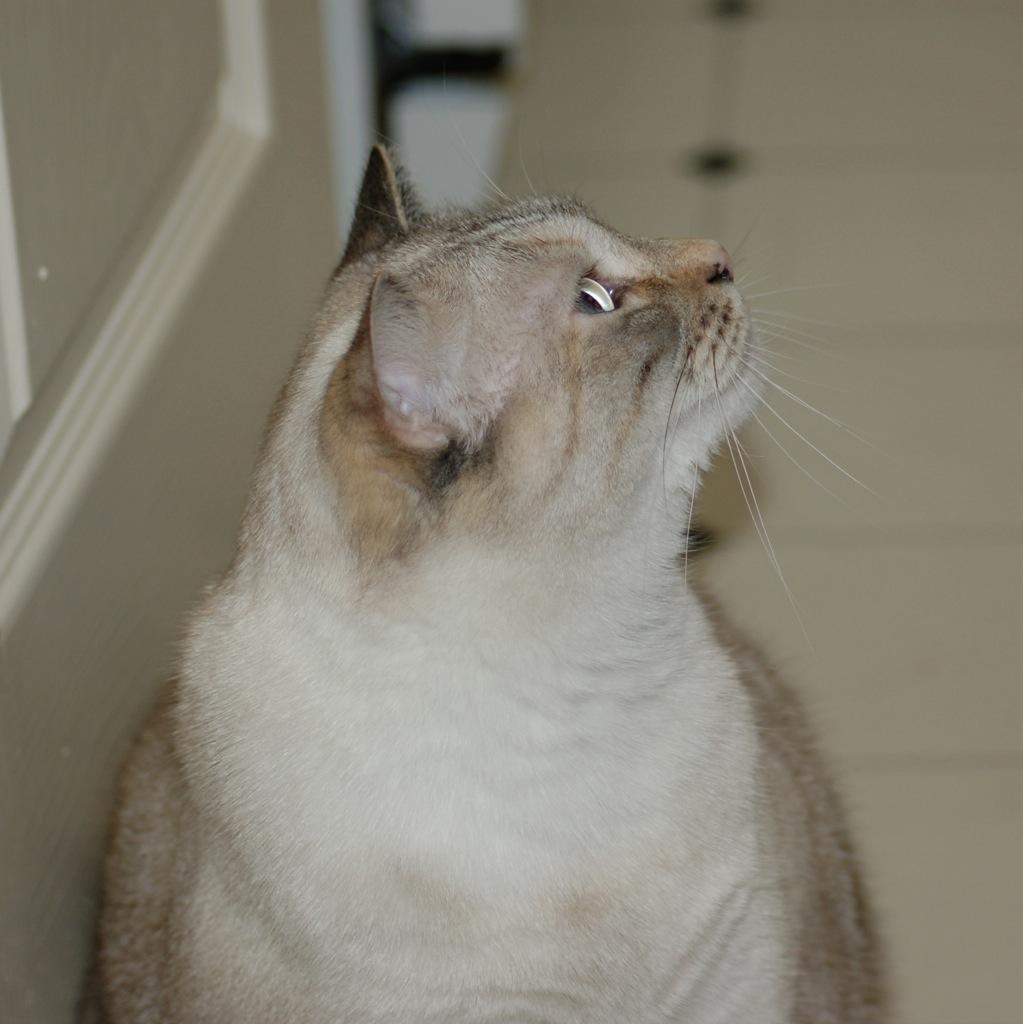In one or two sentences, can you explain what this image depicts? In the foreground of this image, there is a cat on the floor which is looking up side. In the background, there is a floor and the wall. 